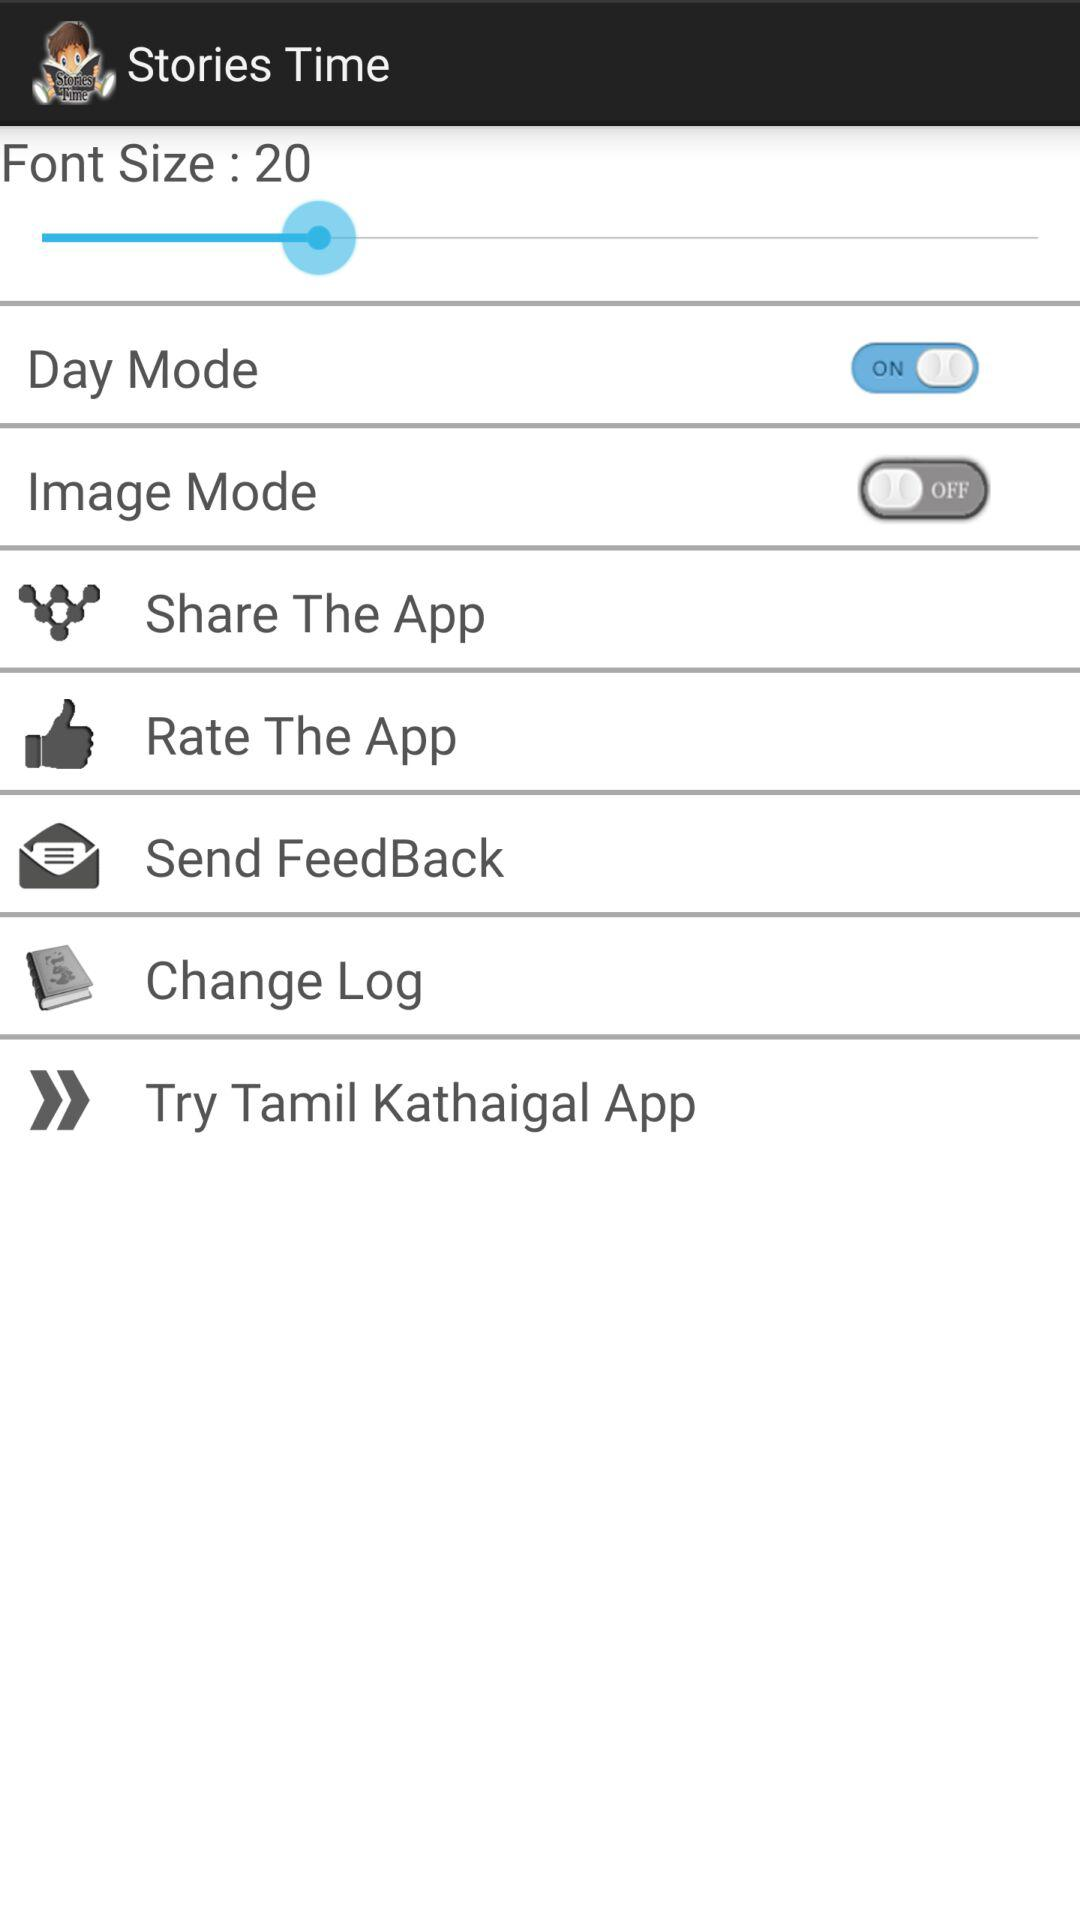How large is the maximum font size?
When the provided information is insufficient, respond with <no answer>. <no answer> 